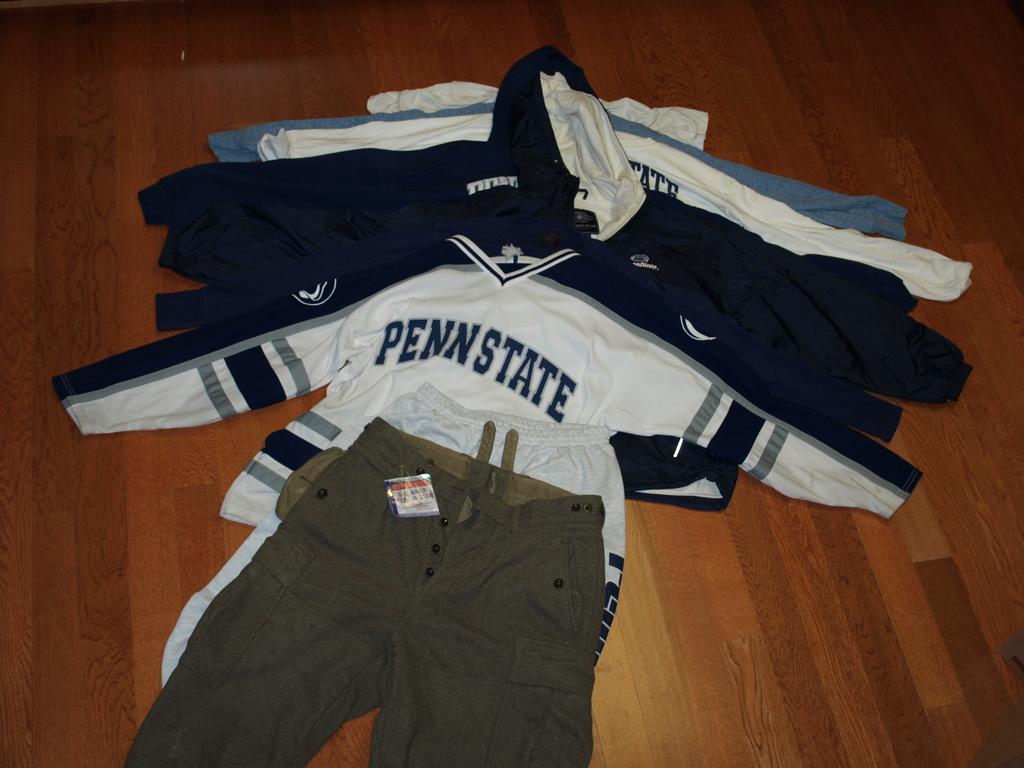What university is advertised on the white shirt on top?
Offer a very short reply. Penn state. 